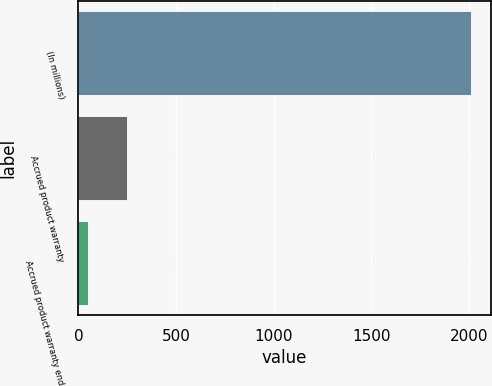Convert chart to OTSL. <chart><loc_0><loc_0><loc_500><loc_500><bar_chart><fcel>(In millions)<fcel>Accrued product warranty<fcel>Accrued product warranty end<nl><fcel>2009<fcel>246.62<fcel>50.8<nl></chart> 